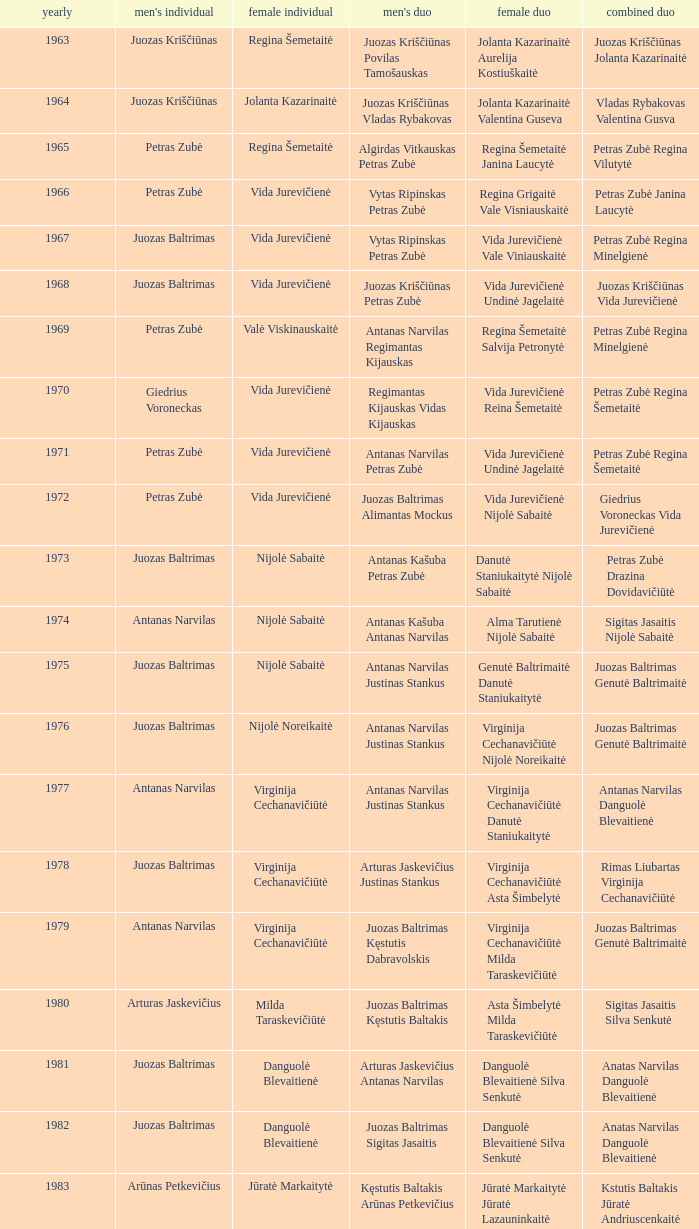Could you parse the entire table? {'header': ['yearly', "men's individual", 'female individual', "men's duo", 'female duo', 'combined duo'], 'rows': [['1963', 'Juozas Kriščiūnas', 'Regina Šemetaitė', 'Juozas Kriščiūnas Povilas Tamošauskas', 'Jolanta Kazarinaitė Aurelija Kostiuškaitė', 'Juozas Kriščiūnas Jolanta Kazarinaitė'], ['1964', 'Juozas Kriščiūnas', 'Jolanta Kazarinaitė', 'Juozas Kriščiūnas Vladas Rybakovas', 'Jolanta Kazarinaitė Valentina Guseva', 'Vladas Rybakovas Valentina Gusva'], ['1965', 'Petras Zubė', 'Regina Šemetaitė', 'Algirdas Vitkauskas Petras Zubė', 'Regina Šemetaitė Janina Laucytė', 'Petras Zubė Regina Vilutytė'], ['1966', 'Petras Zubė', 'Vida Jurevičienė', 'Vytas Ripinskas Petras Zubė', 'Regina Grigaitė Vale Visniauskaitė', 'Petras Zubė Janina Laucytė'], ['1967', 'Juozas Baltrimas', 'Vida Jurevičienė', 'Vytas Ripinskas Petras Zubė', 'Vida Jurevičienė Vale Viniauskaitė', 'Petras Zubė Regina Minelgienė'], ['1968', 'Juozas Baltrimas', 'Vida Jurevičienė', 'Juozas Kriščiūnas Petras Zubė', 'Vida Jurevičienė Undinė Jagelaitė', 'Juozas Kriščiūnas Vida Jurevičienė'], ['1969', 'Petras Zubė', 'Valė Viskinauskaitė', 'Antanas Narvilas Regimantas Kijauskas', 'Regina Šemetaitė Salvija Petronytė', 'Petras Zubė Regina Minelgienė'], ['1970', 'Giedrius Voroneckas', 'Vida Jurevičienė', 'Regimantas Kijauskas Vidas Kijauskas', 'Vida Jurevičienė Reina Šemetaitė', 'Petras Zubė Regina Šemetaitė'], ['1971', 'Petras Zubė', 'Vida Jurevičienė', 'Antanas Narvilas Petras Zubė', 'Vida Jurevičienė Undinė Jagelaitė', 'Petras Zubė Regina Šemetaitė'], ['1972', 'Petras Zubė', 'Vida Jurevičienė', 'Juozas Baltrimas Alimantas Mockus', 'Vida Jurevičienė Nijolė Sabaitė', 'Giedrius Voroneckas Vida Jurevičienė'], ['1973', 'Juozas Baltrimas', 'Nijolė Sabaitė', 'Antanas Kašuba Petras Zubė', 'Danutė Staniukaitytė Nijolė Sabaitė', 'Petras Zubė Drazina Dovidavičiūtė'], ['1974', 'Antanas Narvilas', 'Nijolė Sabaitė', 'Antanas Kašuba Antanas Narvilas', 'Alma Tarutienė Nijolė Sabaitė', 'Sigitas Jasaitis Nijolė Sabaitė'], ['1975', 'Juozas Baltrimas', 'Nijolė Sabaitė', 'Antanas Narvilas Justinas Stankus', 'Genutė Baltrimaitė Danutė Staniukaitytė', 'Juozas Baltrimas Genutė Baltrimaitė'], ['1976', 'Juozas Baltrimas', 'Nijolė Noreikaitė', 'Antanas Narvilas Justinas Stankus', 'Virginija Cechanavičiūtė Nijolė Noreikaitė', 'Juozas Baltrimas Genutė Baltrimaitė'], ['1977', 'Antanas Narvilas', 'Virginija Cechanavičiūtė', 'Antanas Narvilas Justinas Stankus', 'Virginija Cechanavičiūtė Danutė Staniukaitytė', 'Antanas Narvilas Danguolė Blevaitienė'], ['1978', 'Juozas Baltrimas', 'Virginija Cechanavičiūtė', 'Arturas Jaskevičius Justinas Stankus', 'Virginija Cechanavičiūtė Asta Šimbelytė', 'Rimas Liubartas Virginija Cechanavičiūtė'], ['1979', 'Antanas Narvilas', 'Virginija Cechanavičiūtė', 'Juozas Baltrimas Kęstutis Dabravolskis', 'Virginija Cechanavičiūtė Milda Taraskevičiūtė', 'Juozas Baltrimas Genutė Baltrimaitė'], ['1980', 'Arturas Jaskevičius', 'Milda Taraskevičiūtė', 'Juozas Baltrimas Kęstutis Baltakis', 'Asta Šimbelytė Milda Taraskevičiūtė', 'Sigitas Jasaitis Silva Senkutė'], ['1981', 'Juozas Baltrimas', 'Danguolė Blevaitienė', 'Arturas Jaskevičius Antanas Narvilas', 'Danguolė Blevaitienė Silva Senkutė', 'Anatas Narvilas Danguolė Blevaitienė'], ['1982', 'Juozas Baltrimas', 'Danguolė Blevaitienė', 'Juozas Baltrimas Sigitas Jasaitis', 'Danguolė Blevaitienė Silva Senkutė', 'Anatas Narvilas Danguolė Blevaitienė'], ['1983', 'Arūnas Petkevičius', 'Jūratė Markaitytė', 'Kęstutis Baltakis Arūnas Petkevičius', 'Jūratė Markaitytė Jūratė Lazauninkaitė', 'Kstutis Baltakis Jūratė Andriuscenkaitė'], ['1984', 'Arūnas Petkevičius', 'Jūratė Markaitytė', 'Kęstutis Baltakis Arūnas Petkevičius', 'Jūratė Markaitytė Edita Andriuscenkaitė', 'Arūnas Petkevičius Jūratė Markaitytė'], ['1985', 'Arūnas Petkevičius', 'Jūratė Markaitytė', 'Kęstutis Baltakis Arūnas Petkevičius', 'Jūratė Markaitytė Silva Senkutė', 'Arūnas Petkevičius Jūratė Markaitytė'], ['1986', 'Arūnas Petkevičius', 'Jūratė Markaitytė', 'Kęstutis Baltakis Arūnas Petkevičius', 'Jūratė Markaitytė Aušrinė Gebranaitė', 'Egidijus Jankauskas Jūratė Markaitytė'], ['1987', 'Egidijus Jankauskas', 'Jūratė Markaitytė', 'Kęstutis Baltakis Arūnas Petkevičius', 'Jūratė Markaitytė Danguolė Blevaitienė', 'Egidijus Jankauskas Danguolė Blevaitienė'], ['1988', 'Arūnas Petkevičius', 'Rasa Mikšytė', 'Algirdas Kepežinskas Ovidius Česonis', 'Jūratė Markaitytė Danguolė Blevaitienė', 'Arūnas Petkevičius Danguolė Blevaitienė'], ['1989', 'Ovidijus Cesonis', 'Aušrinė Gabrenaitė', 'Egidijus Jankauskus Ovidius Česonis', 'Aušrinė Gebranaitė Rasa Mikšytė', 'Egidijus Jankauskas Aušrinė Gabrenaitė'], ['1990', 'Aivaras Kvedarauskas', 'Rasa Mikšytė', 'Algirdas Kepežinskas Ovidius Česonis', 'Jūratė Markaitytė Danguolė Blevaitienė', 'Aivaras Kvedarauskas Rasa Mikšytė'], ['1991', 'Egidius Jankauskas', 'Rasa Mikšytė', 'Egidijus Jankauskus Ovidius Česonis', 'Rasa Mikšytė Solveiga Stasaitytė', 'Algirdas Kepežinskas Rasa Mikšytė'], ['1992', 'Egidius Jankauskas', 'Rasa Mikšytė', 'Aivaras Kvedarauskas Vygandas Virzintas', 'Rasa Mikšytė Solveiga Stasaitytė', 'Algirdas Kepežinskas Rasa Mikšytė'], ['1993', 'Edigius Jankauskas', 'Solveiga Stasaitytė', 'Edigius Jankauskas Aivaras Kvedarauskas', 'Rasa Mikšytė Solveiga Stasaitytė', 'Edigius Jankauskas Solveiga Stasaitytė'], ['1994', 'Aivaras Kvedarauskas', 'Aina Kravtienė', 'Aivaras Kvedarauskas Ovidijus Zukauskas', 'Indre Ivanauskaitė Rasa Mikšytė', 'Aivaras Kvedarauskas Indze Ivanauskaitė'], ['1995', 'Aivaras Kvedarauskas', 'Rasa Mikšytė', 'Algirdas Kepežinskas Aivaras Kvedarauskas', 'Indre Ivanauskaitė Rasa Mikšytė', 'Aivaras Kvedarauskas Rasa Mikšytė'], ['1996', 'Aivaras Kvedarauskas', 'Rasa Myksite', 'Aivaras Kvedarauskas Donatas Vievesis', 'Indre Ivanauskaitė Rasa Mikšytė', 'Aivaras Kvedarauskas Rasa Mikšytė'], ['1997', 'Aivaras Kvedarauskas', 'Rasa Myksite', 'Aivaras Kvedarauskas Gediminas Andrikonis', 'Neringa Karosaitė Aina Kravtienė', 'Aivaras Kvedarauskas Rasa Mikšytė'], ['1998', 'Aivaras Kvedarauskas', 'Neringa Karosaitė', 'Aivaras Kvedarauskas Dainius Mikalauskas', 'Rasa Mikšytė Jūratė Prevelienė', 'Aivaras Kvedarauskas Jūratė Prevelienė'], ['1999', 'Aivaras Kvedarauskas', 'Erika Milikauskaitė', 'Aivaras Kvedarauskas Dainius Mikalauskas', 'Rasa Mikšytė Jūratė Prevelienė', 'Aivaras Kvedarauskas Rasa Mikšytė'], ['2000', 'Aivaras Kvedarauskas', 'Erika Milikauskaitė', 'Aivaras Kvedarauskas Donatas Vievesis', 'Kristina Dovidaitytė Neringa Karosaitė', 'Aivaras Kvedarauskas Jūratė Prevelienė'], ['2001', 'Aivaras Kvedarauskas', 'Neringa Karosaitė', 'Aivaras Kvedarauskas Juozas Spelveris', 'Kristina Dovidaitytė Neringa Karosaitė', 'Aivaras Kvedarauskas Ligita Zakauskaitė'], ['2002', 'Aivaras Kvedarauskas', 'Erika Milikauskaitė', 'Aivaras Kvedarauskas Kęstutis Navickas', 'Kristina Dovidaitytė Neringa Karosaitė', 'Aivaras Kvedarauskas Jūratė Prevelienė'], ['2003', 'Aivaras Kvedarauskas', 'Ugnė Urbonaitė', 'Aivaras Kvedarauskas Dainius Mikalauskas', 'Ugnė Urbonaitė Kristina Dovidaitytė', 'Aivaras Kvedarauskas Ugnė Urbonaitė'], ['2004', 'Kęstutis Navickas', 'Ugnė Urbonaitė', 'Kęstutis Navickas Klaudijus Kasinskis', 'Ugnė Urbonaitė Akvilė Stapušaitytė', 'Kęstutis Navickas Ugnė Urbonaitė'], ['2005', 'Kęstutis Navickas', 'Ugnė Urbonaitė', 'Kęstutis Navickas Klaudijus Kasinskis', 'Ugnė Urbonaitė Akvilė Stapušaitytė', 'Donatas Narvilas Kristina Dovidaitytė'], ['2006', 'Šarūnas Bilius', 'Akvilė Stapušaitytė', 'Deividas Butkus Klaudijus Kašinskis', 'Akvilė Stapušaitytė Ligita Žukauskaitė', 'Donatas Narvilas Kristina Dovidaitytė'], ['2007', 'Kęstutis Navickas', 'Akvilė Stapušaitytė', 'Kęstutis Navickas Klaudijus Kašinskis', 'Gerda Voitechovskaja Kristina Dovidaitytė', 'Kęstutis Navickas Indrė Starevičiūtė'], ['2008', 'Kęstutis Navickas', 'Akvilė Stapušaitytė', 'Paulius Geležiūnas Ramūnas Stapušaitis', 'Gerda Voitechovskaja Kristina Dovidaitytė', 'Kęstutis Navickas Akvilė Stapušaitytė'], ['2009', 'Kęstutis Navickas', 'Akvilė Stapušaitytė', 'Kęstutis Navickas Klaudijus Kašinskis', 'Akvilė Stapušaitytė Ligita Žukauskaitė', 'Kęstutis Navickas Akvilė Stapušaitytė']]} How many years did aivaras kvedarauskas juozas spelveris participate in the men's doubles? 1.0. 